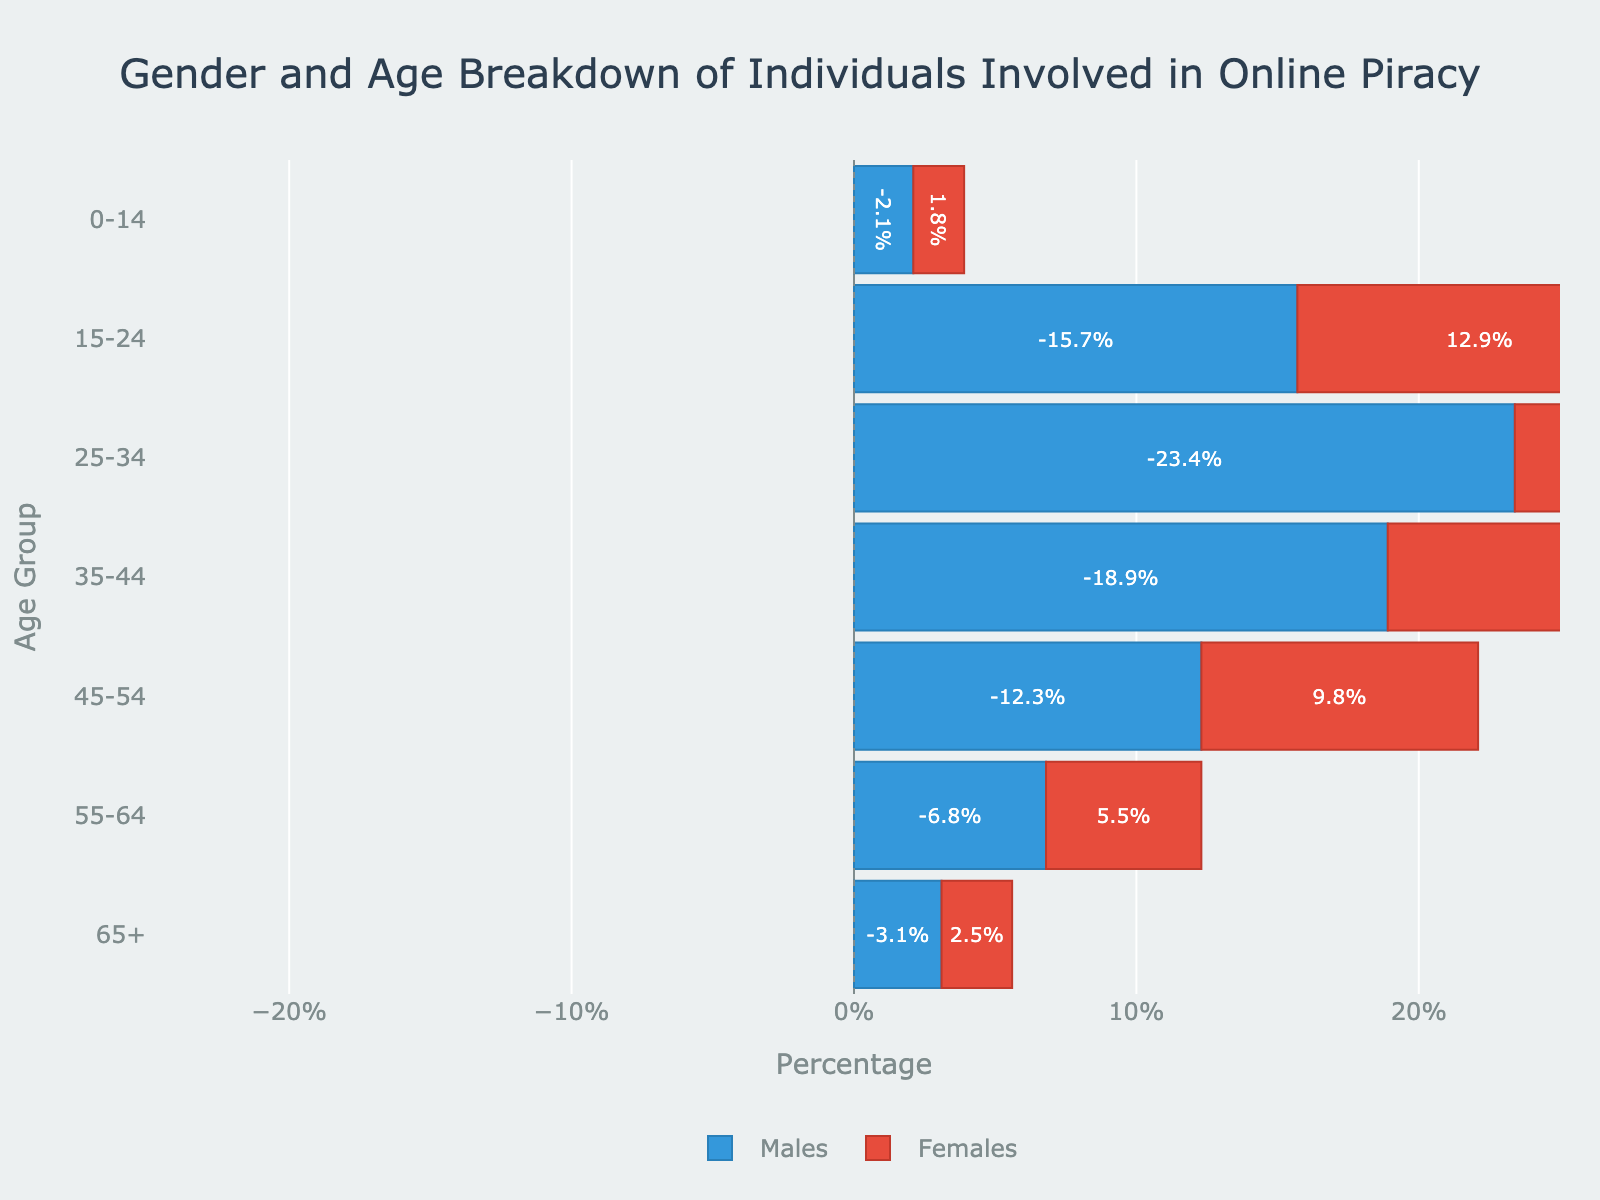How many age groups are represented in the gender and age breakdown of individuals involved in online piracy? There are seven different age groups represented in the figure. Each bar on the pyramid corresponds to one of these age groups.
Answer: 7 Which age group has the highest percentage of males involved in online piracy? The highest bar on the male side can be observed in the age group '25-34', where the percentage of males reaches -23.4%.
Answer: 25-34 What is the total percentage of females involved in piracy in the '35-44' and '45-54' age groups? The figure shows that the percentage of females in '35-44' is 15.2% and in '45-54' is 9.8%. Summing these values gives \(15.2 + 9.8 = 25\).
Answer: 25% How do the percentages of males and females compare in the '0-14' age group? The figure illustrates that in the '0-14' age group, the percentage of males involved in piracy is -2.1% while for females it is 1.8%. This shows that males have a higher percentage than females.
Answer: males > females Which gender shows a closer resemblance in involvement in piracy in the '65+' age group? In the '65+' age group, the involvement percentages are -3.1% for males and 2.5% for females. These values are quite close compared to other age groups.
Answer: both are close 